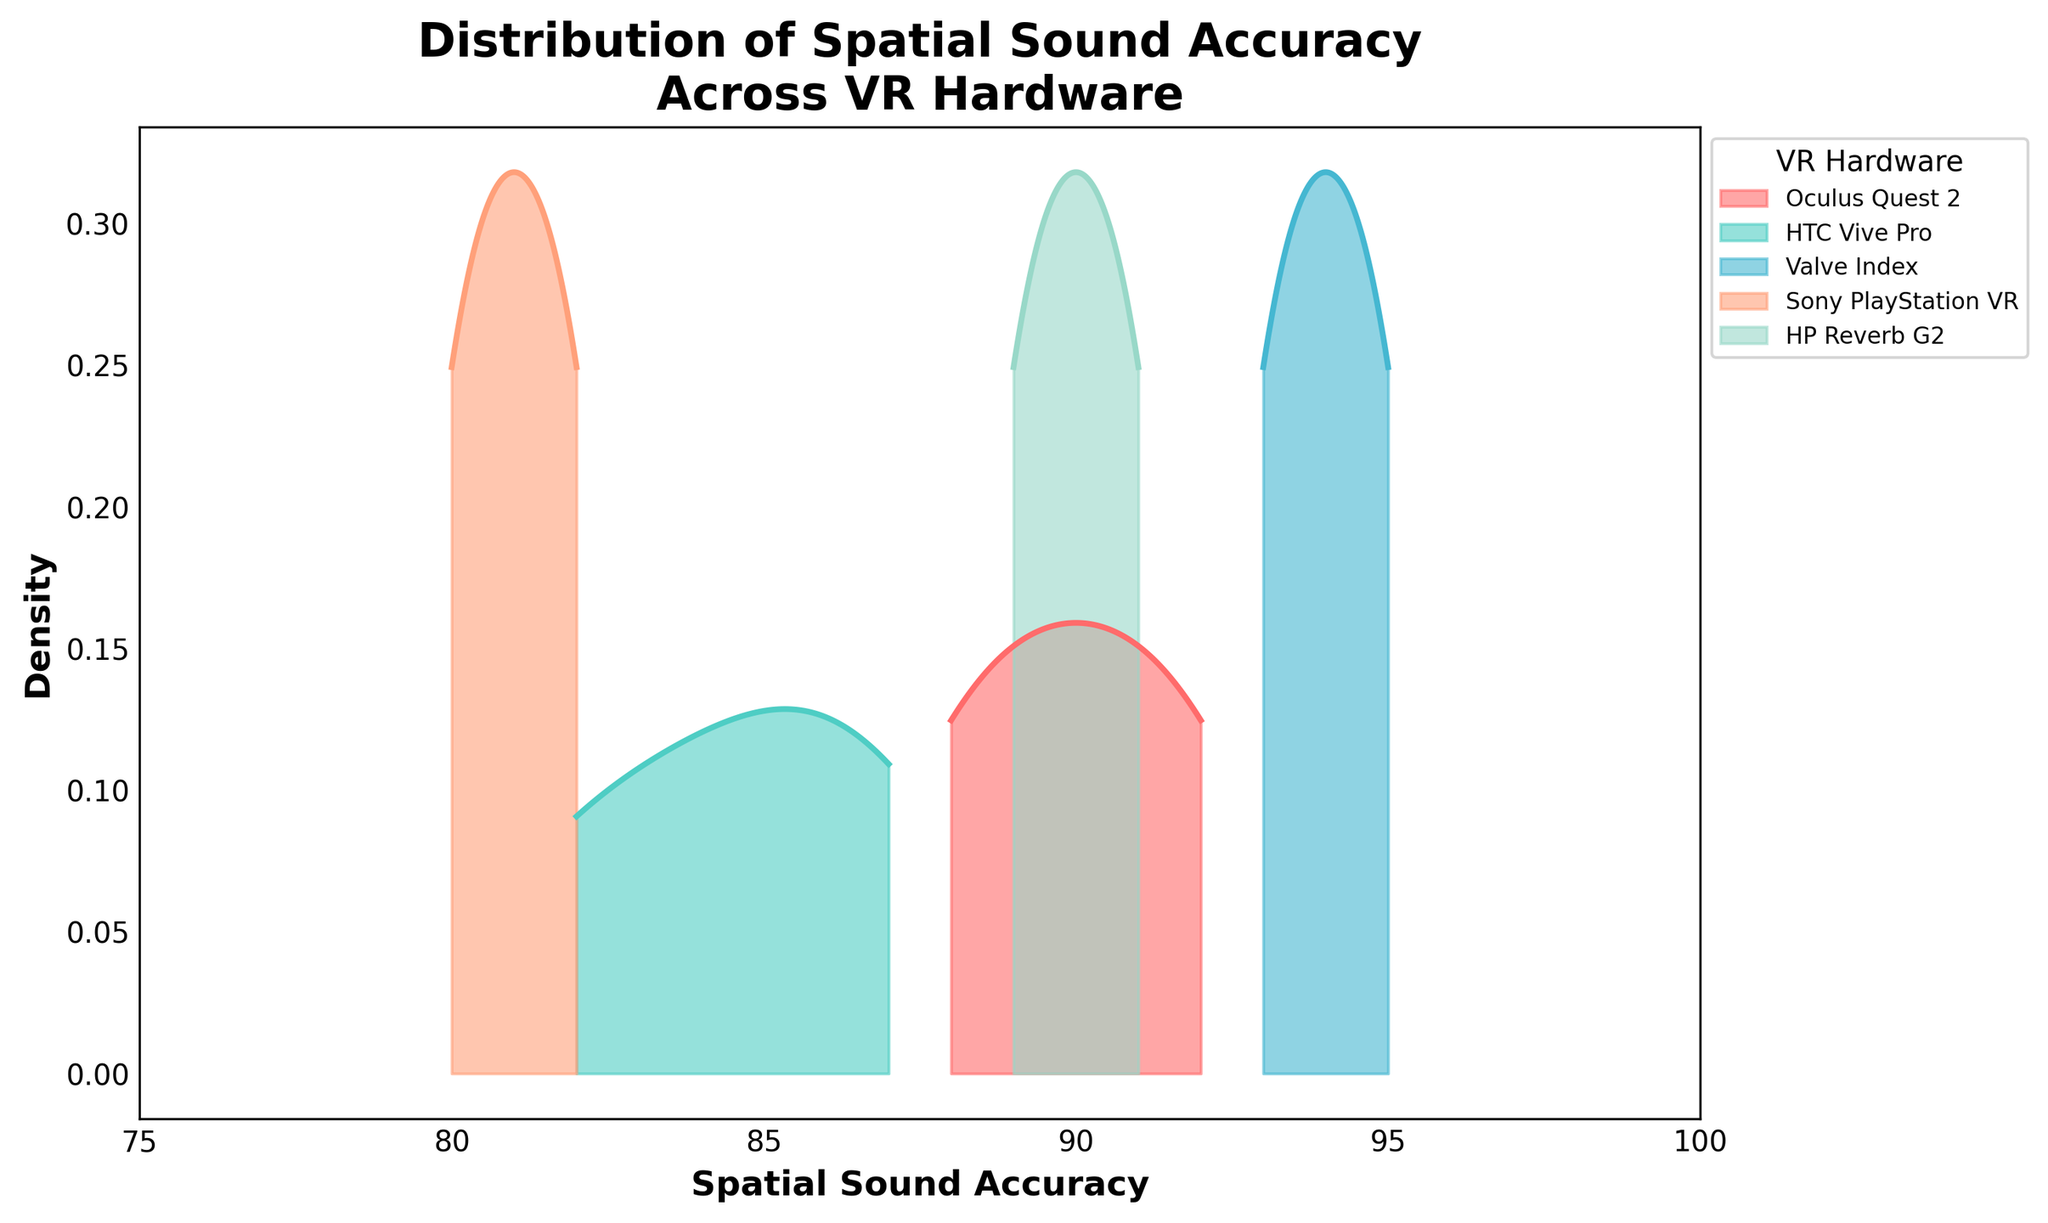What's the title of the figure? The title is located at the top of the figure. It summarizes the main topic of the visualization.
Answer: Distribution of Spatial Sound Accuracy Across VR Hardware What does the x-axis represent? The x-axis label is found below the horizontal axis and indicates what the horizontal values correspond to.
Answer: Spatial Sound Accuracy What does the y-axis represent? The y-axis label is found beside the vertical axis and specifies what the vertical values represent.
Answer: Density Which VR hardware has the highest peak density in spatial sound accuracy? The highest peak density is the maximum point of the curve that represents the frequency distribution. Identify the curve with the highest peak.
Answer: Valve Index Which VR hardware has spatial sound accuracies predominantly between 80 and 85? Look for the density plot(s) where most of the distribution is within the range of 80 to 85 on the x-axis.
Answer: Sony PlayStation VR At which intervals on the x-axis are the ticks set? The x-axis ticks are evenly spaced markers indicating specific values along the x-axis. Identify these values.
Answer: 75, 80, 85, 90, 95, 100 How do the distributions of spatial sound accuracy for Oculus Quest 2 and HP Reverb G2 compare? Compare the two density plots visually. Note peaks, spread, and symmetry to determine similarities or differences.
Answer: They have similar distributions with overlapping peaks around 89-92 What can you infer about the VR hardware with the lowest average spatial sound accuracy? Identify the VR hardware with the density plot shifted most towards the lower end of the x-axis and analyze its distribution.
Answer: Sony PlayStation VR How does the spread of the spatial sound accuracy of HTC Vive Pro compare to Oculus Quest 2? Compare the width of the density plots. A wider spread suggests more variability in the data.
Answer: HTC Vive Pro has a wider spread than Oculus Quest 2 Which VR hardware has a more concentrated distribution around a single value, implying less variability in spatial sound accuracy? Look for a density plot that is narrow and peaked, indicating low variability around a central value.
Answer: Valve Index 